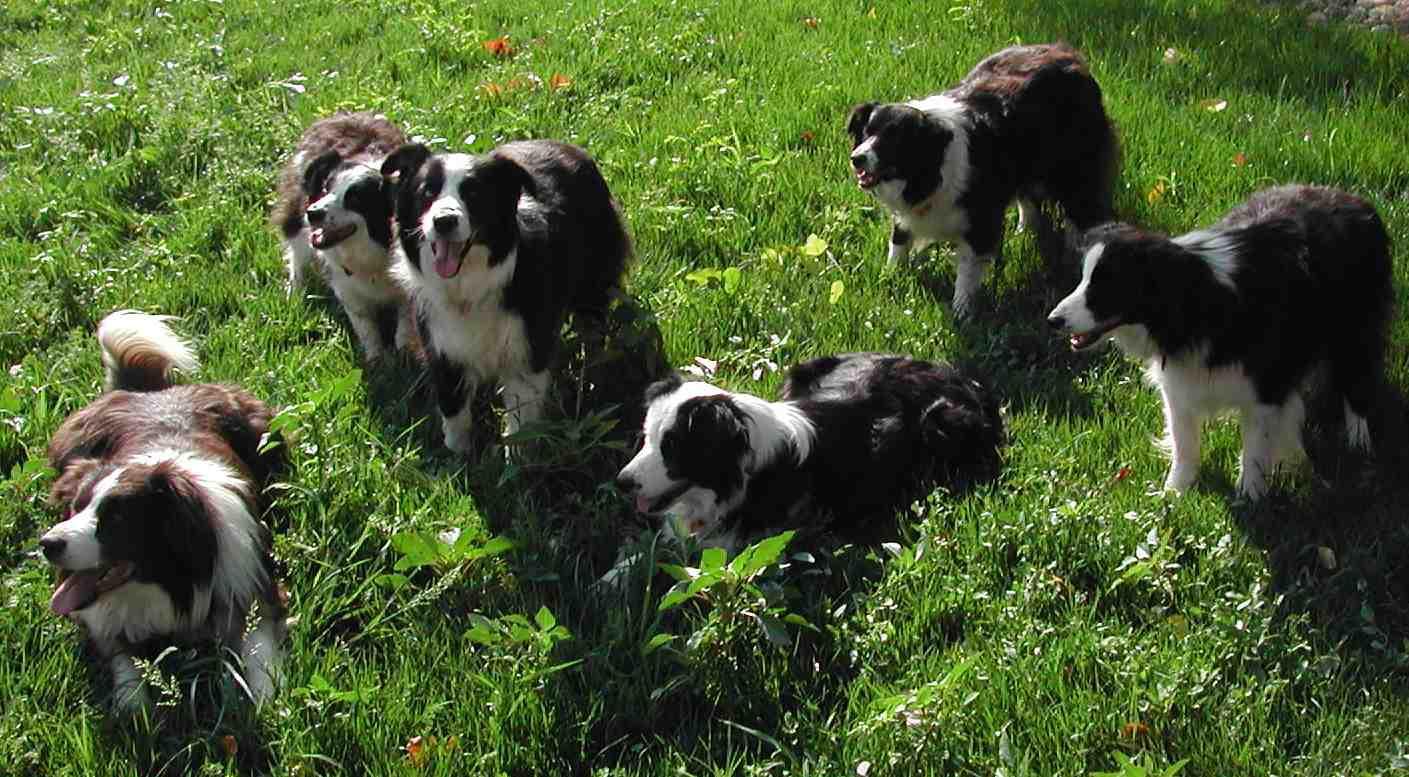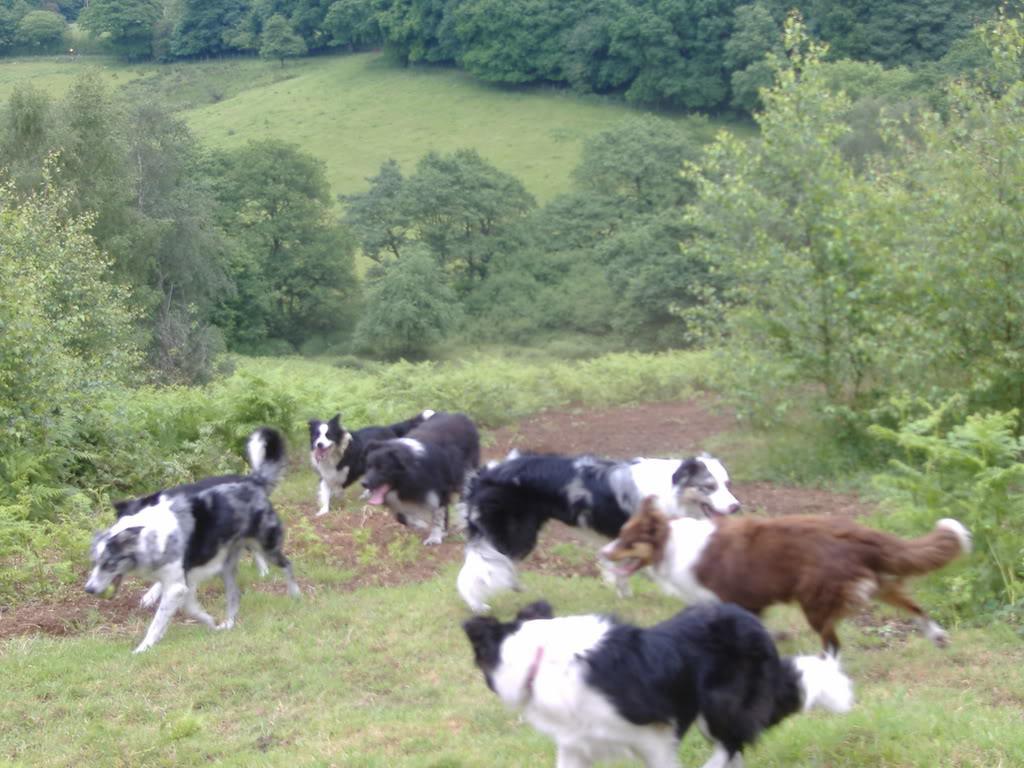The first image is the image on the left, the second image is the image on the right. Evaluate the accuracy of this statement regarding the images: "There are exactly seven dogs in the image on the right.". Is it true? Answer yes or no. Yes. 